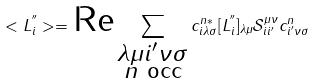<formula> <loc_0><loc_0><loc_500><loc_500>< { L } ^ { ^ { \prime \prime } } _ { i } > = \text {Re} \sum _ { \substack { \lambda \mu i ^ { \prime } \nu \sigma \\ n \text { occ} } } c ^ { n * } _ { i \lambda \sigma } [ { L } ^ { ^ { \prime \prime } } _ { i } ] _ { \lambda \mu } \mathcal { S } ^ { \mu \nu } _ { i i ^ { \prime } } c ^ { n } _ { i ^ { \prime } \nu \sigma }</formula> 